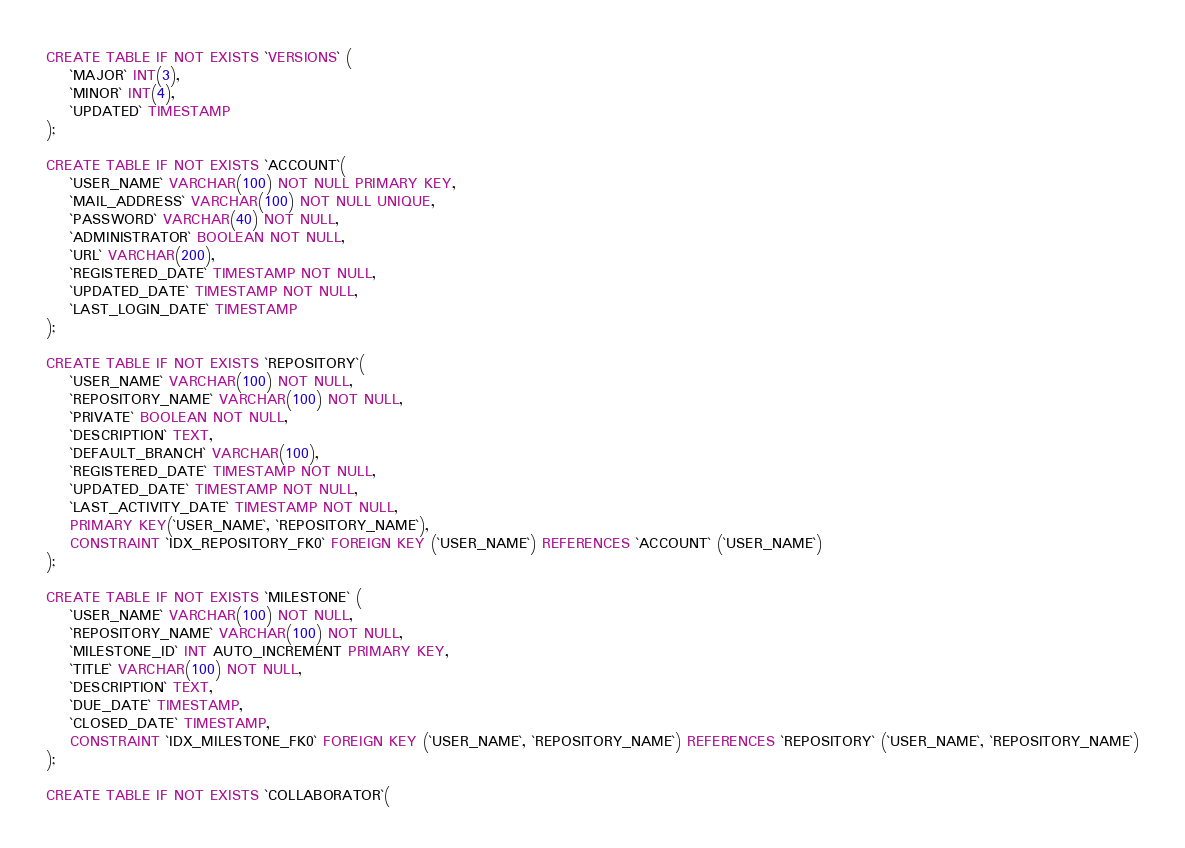Convert code to text. <code><loc_0><loc_0><loc_500><loc_500><_SQL_>CREATE TABLE IF NOT EXISTS `VERSIONS` (
	`MAJOR` INT(3),
	`MINOR` INT(4),
	`UPDATED` TIMESTAMP
);

CREATE TABLE IF NOT EXISTS `ACCOUNT`(
    `USER_NAME` VARCHAR(100) NOT NULL PRIMARY KEY,
	`MAIL_ADDRESS` VARCHAR(100) NOT NULL UNIQUE,
	`PASSWORD` VARCHAR(40) NOT NULL,
	`ADMINISTRATOR` BOOLEAN NOT NULL,
	`URL` VARCHAR(200),
	`REGISTERED_DATE` TIMESTAMP NOT NULL,
	`UPDATED_DATE` TIMESTAMP NOT NULL,
	`LAST_LOGIN_DATE` TIMESTAMP
);

CREATE TABLE IF NOT EXISTS `REPOSITORY`(
	`USER_NAME` VARCHAR(100) NOT NULL,
	`REPOSITORY_NAME` VARCHAR(100) NOT NULL,
	`PRIVATE` BOOLEAN NOT NULL,
	`DESCRIPTION` TEXT,
	`DEFAULT_BRANCH` VARCHAR(100),
	`REGISTERED_DATE` TIMESTAMP NOT NULL,
	`UPDATED_DATE` TIMESTAMP NOT NULL,
	`LAST_ACTIVITY_DATE` TIMESTAMP NOT NULL,
	PRIMARY KEY(`USER_NAME`, `REPOSITORY_NAME`),
	CONSTRAINT `IDX_REPOSITORY_FK0` FOREIGN KEY (`USER_NAME`) REFERENCES `ACCOUNT` (`USER_NAME`)
);

CREATE TABLE IF NOT EXISTS `MILESTONE` (
	`USER_NAME` VARCHAR(100) NOT NULL,
	`REPOSITORY_NAME` VARCHAR(100) NOT NULL,
	`MILESTONE_ID` INT AUTO_INCREMENT PRIMARY KEY,
	`TITLE` VARCHAR(100) NOT NULL,
	`DESCRIPTION` TEXT,
	`DUE_DATE` TIMESTAMP,
	`CLOSED_DATE` TIMESTAMP,
	CONSTRAINT `IDX_MILESTONE_FK0` FOREIGN KEY (`USER_NAME`, `REPOSITORY_NAME`) REFERENCES `REPOSITORY` (`USER_NAME`, `REPOSITORY_NAME`)
);

CREATE TABLE IF NOT EXISTS `COLLABORATOR`(</code> 